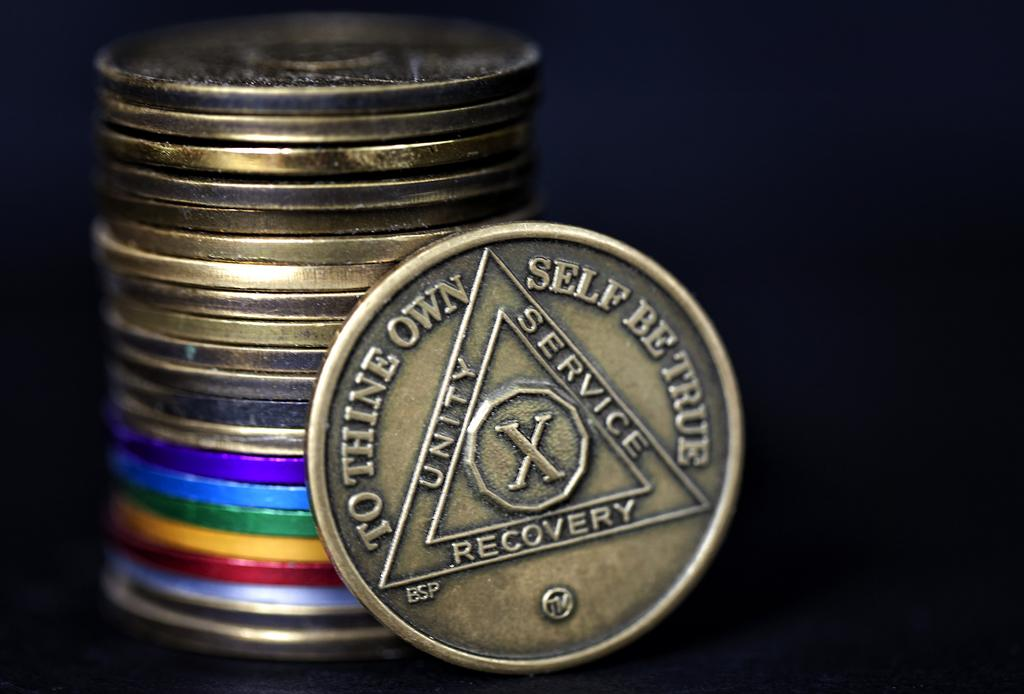<image>
Relay a brief, clear account of the picture shown. Bronze coin that says To Thine Own Self Be True Unity Service an X in a circle  Recovery 